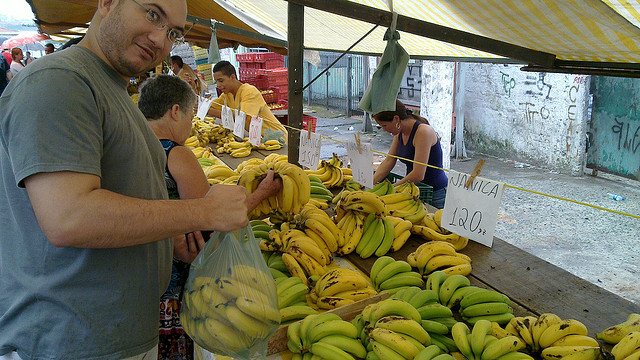<image>How much are the bananas? I don't know how much the bananas are. How much are the bananas? I don't know how much are the bananas. But it is possible that they are priced at 120. 